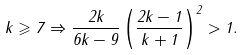Convert formula to latex. <formula><loc_0><loc_0><loc_500><loc_500>k \geqslant 7 \Rightarrow \frac { 2 k } { 6 k - 9 } \left ( \frac { 2 k - 1 } { k + 1 } \right ) ^ { 2 } > 1 .</formula> 